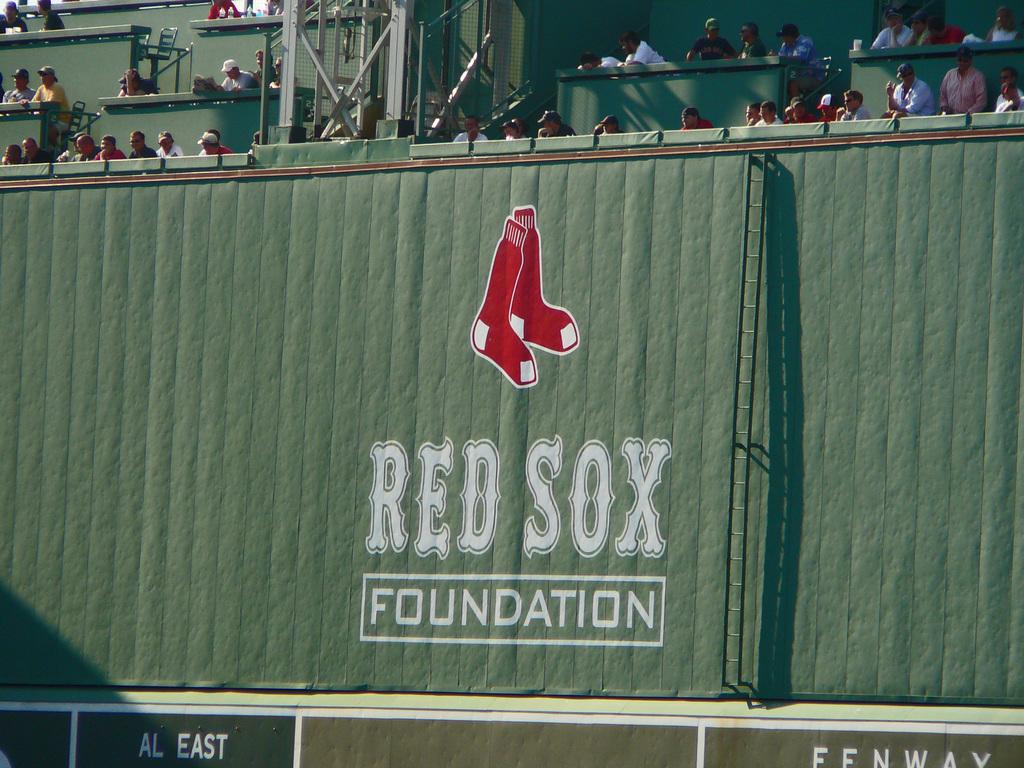What is the foundation of the baseball field?
Make the answer very short. Red sox foundation. What is the name of the park?
Give a very brief answer. Fenway. 